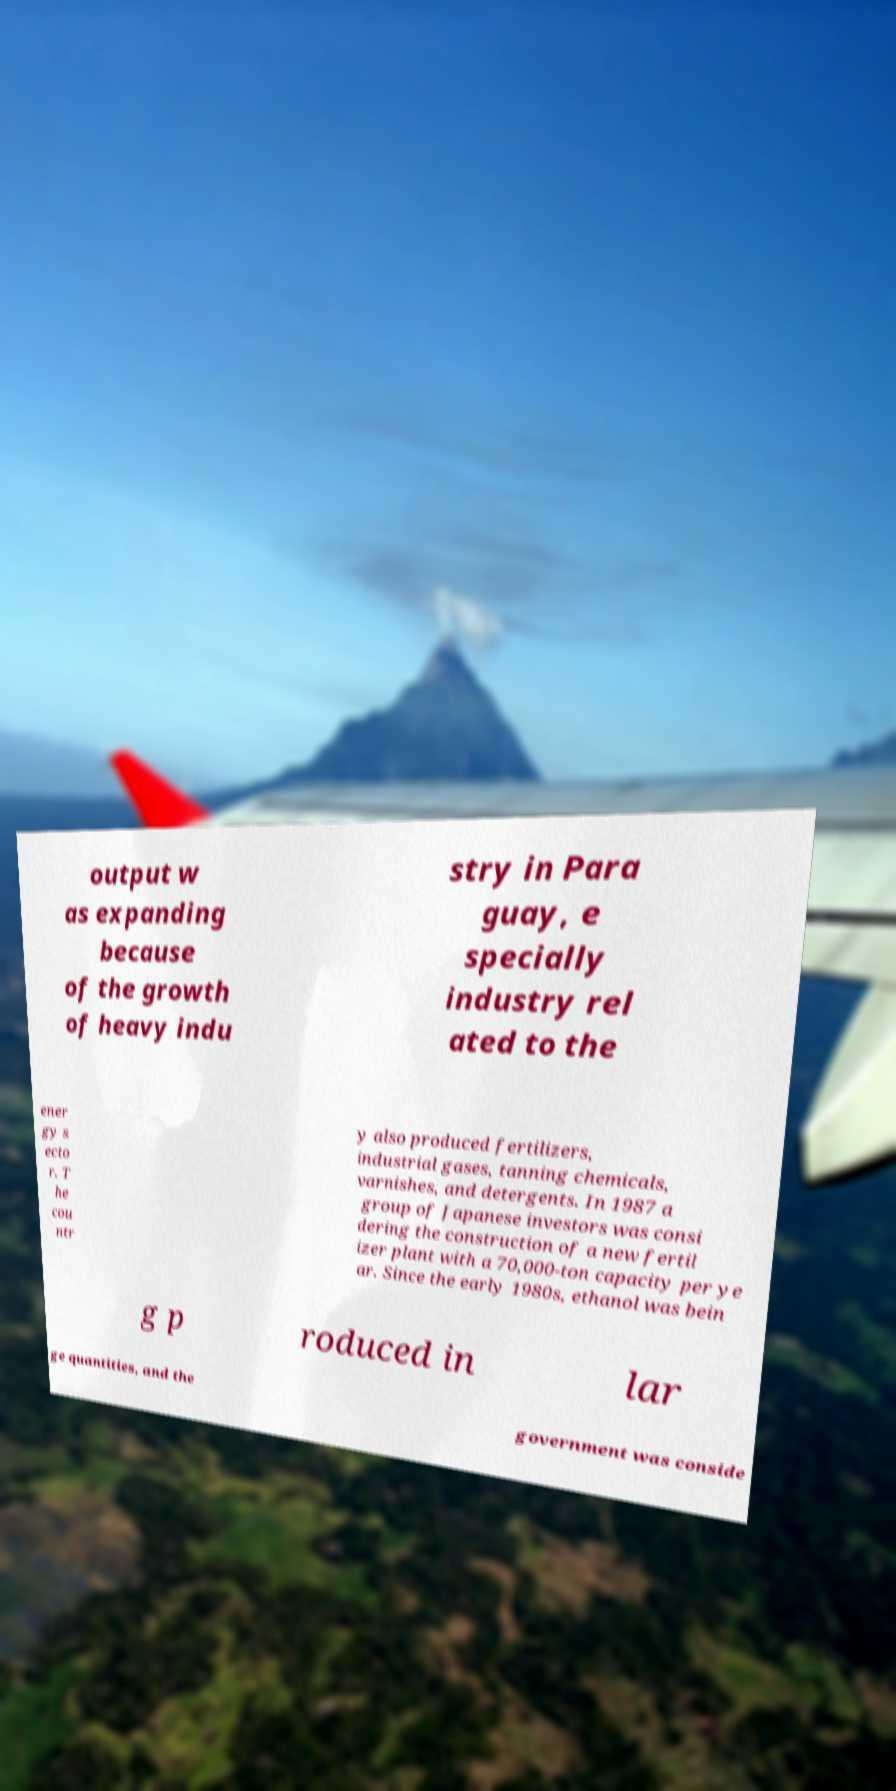What messages or text are displayed in this image? I need them in a readable, typed format. output w as expanding because of the growth of heavy indu stry in Para guay, e specially industry rel ated to the ener gy s ecto r. T he cou ntr y also produced fertilizers, industrial gases, tanning chemicals, varnishes, and detergents. In 1987 a group of Japanese investors was consi dering the construction of a new fertil izer plant with a 70,000-ton capacity per ye ar. Since the early 1980s, ethanol was bein g p roduced in lar ge quantities, and the government was conside 